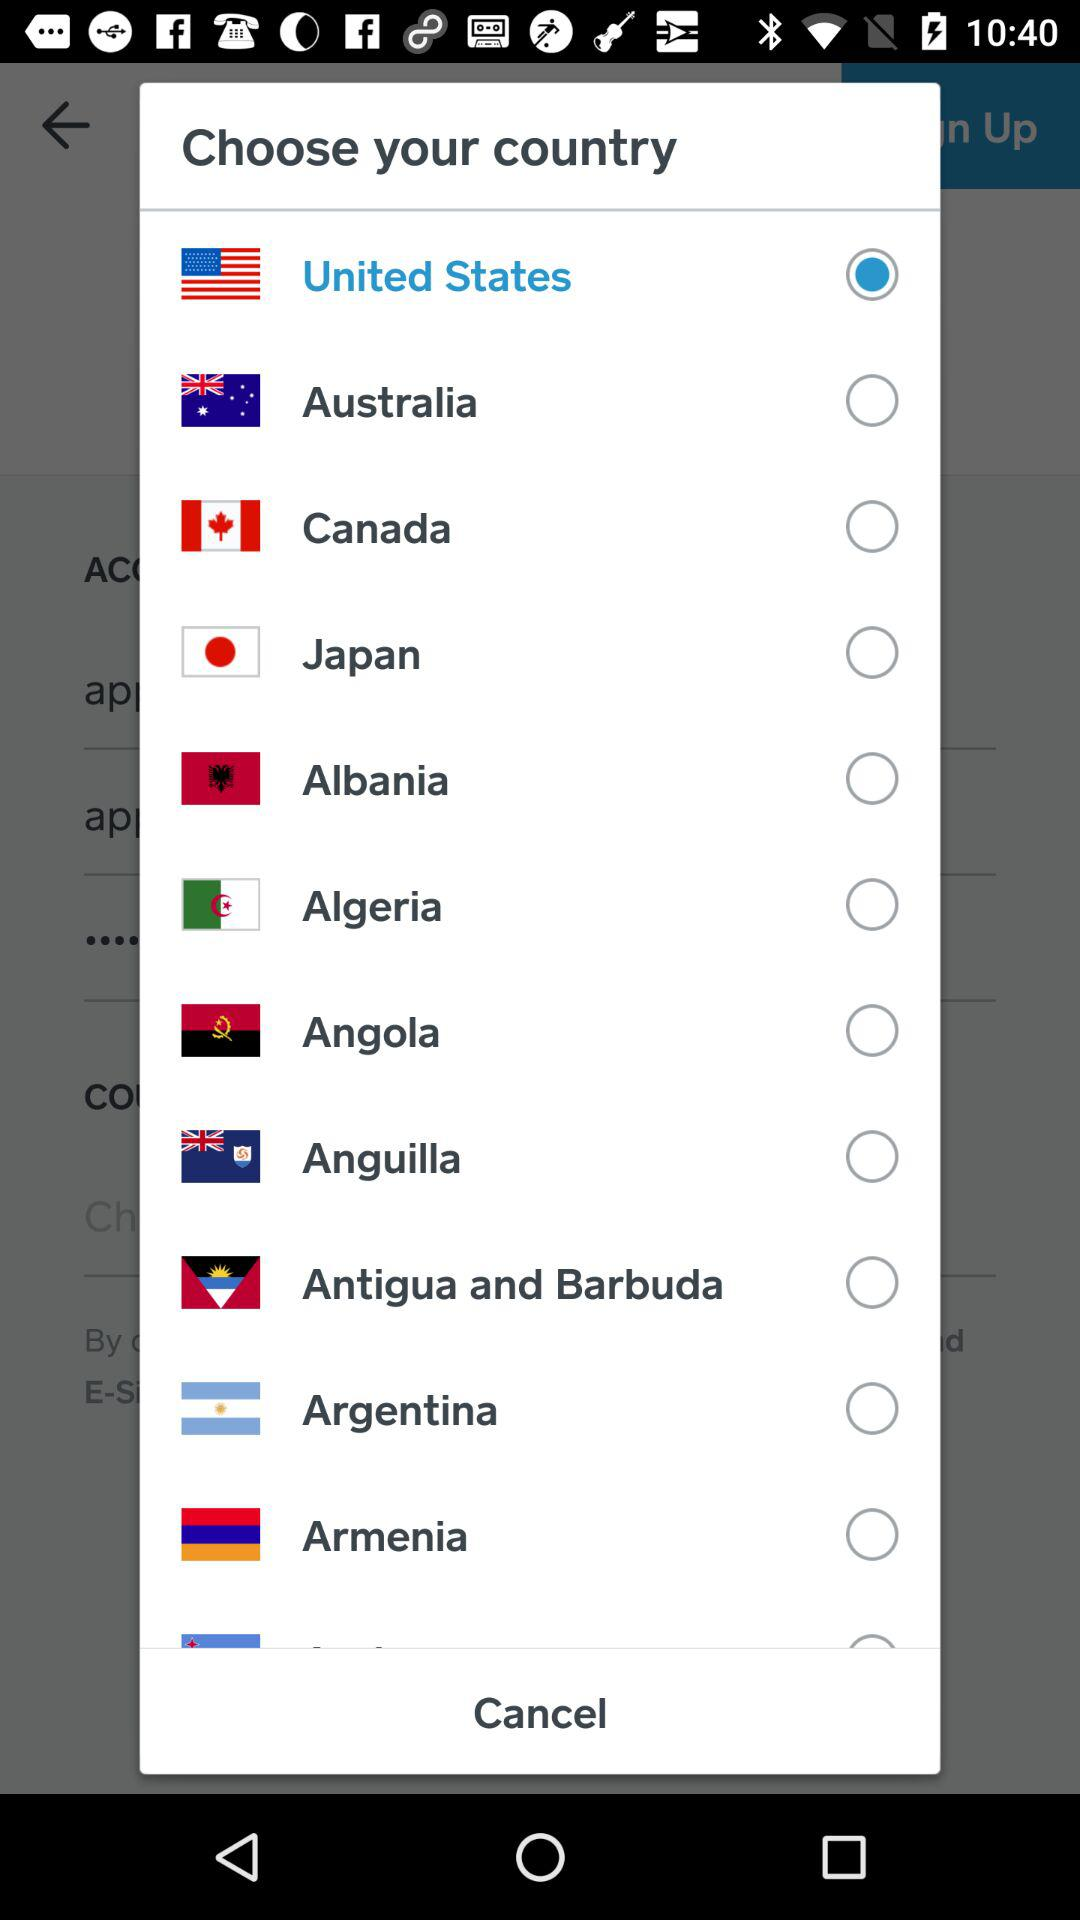Which country is selected? The selected country is the United States. 